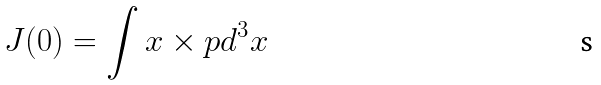<formula> <loc_0><loc_0><loc_500><loc_500>J ( 0 ) = \int x \times p d ^ { 3 } x</formula> 